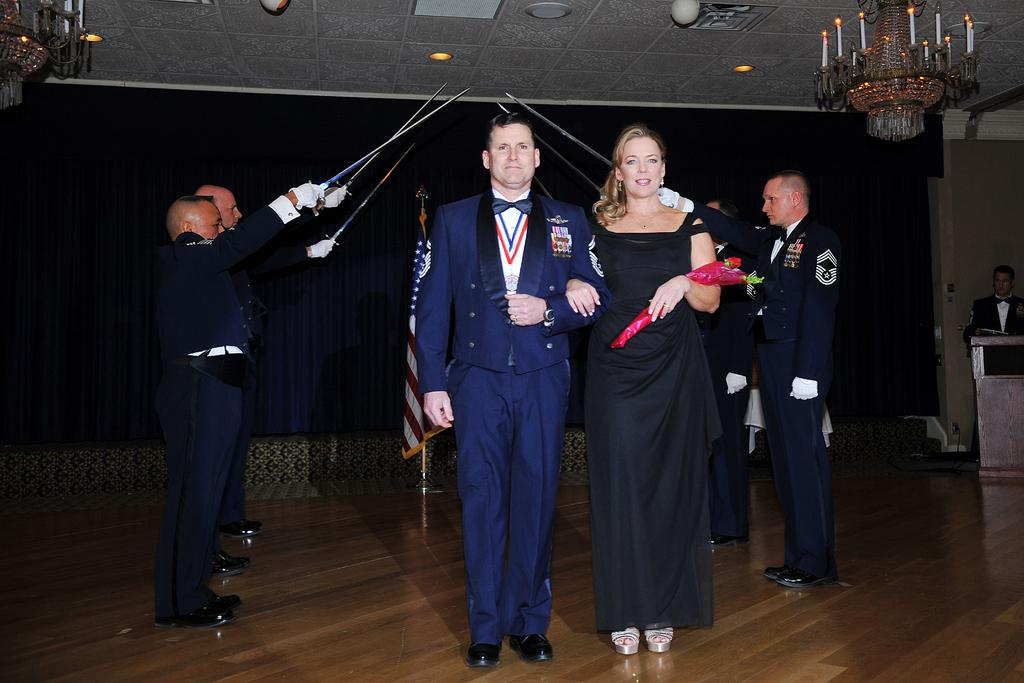Who are the people in the image? There is a man and a woman in the image. What are the man and woman doing in the image? The man and woman are standing on a surface. What else can be seen in the image? There are people holding weapons and chandeliers visible in the image. What is the lighting situation in the image? There are light arrangements on the roof. What type of appliance is being used by the man in the image? There is no appliance being used by the man in the image. Can you tell me how many knives are being held by the woman in the image? The image does not specify the number of weapons being held by the woman, only that she is holding one. 